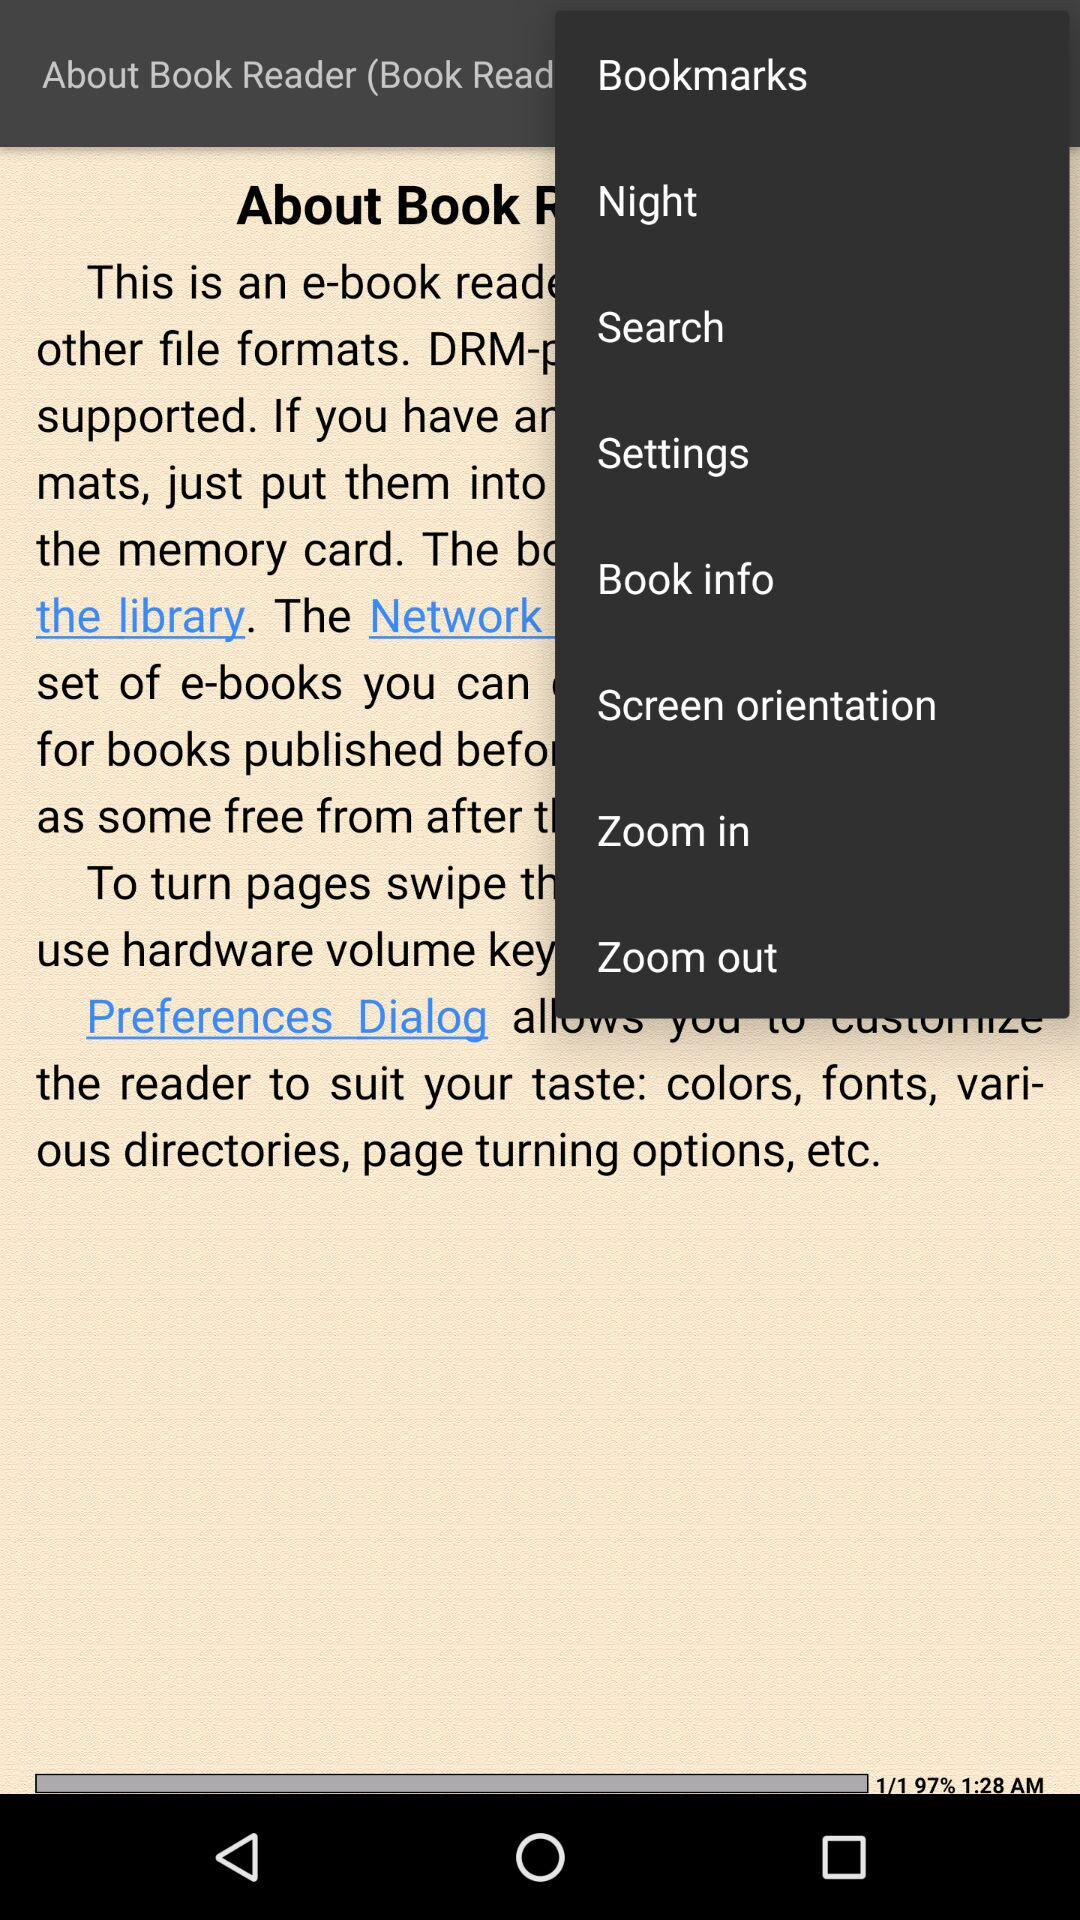Which page are we currently on? You are currently on page 1. 